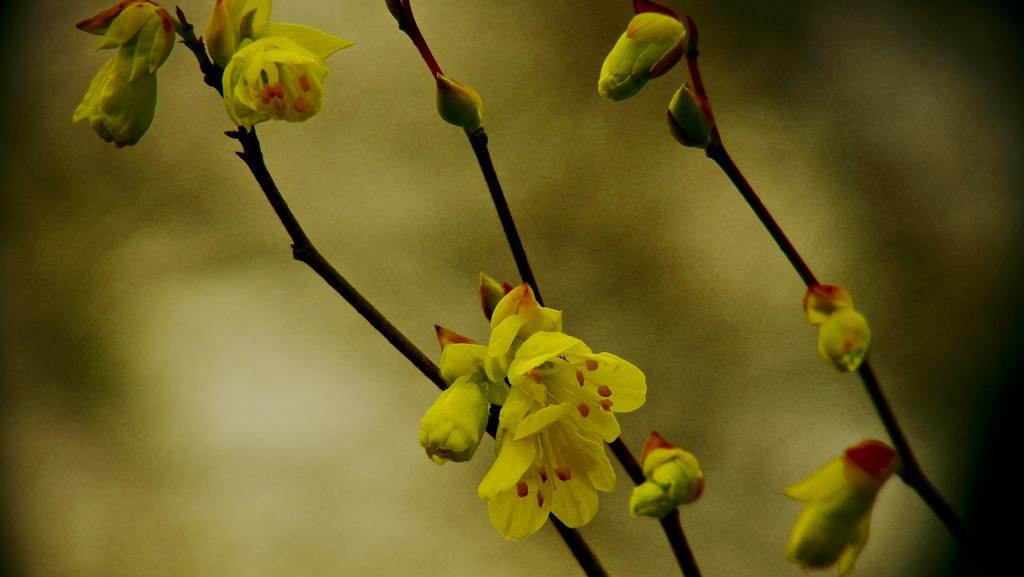What is located in the foreground of the image? There are flowers, buds, and stems in the foreground of the image. Can you describe the appearance of the flowers? The flowers are likely in various stages of blooming, as there are both buds and open flowers visible. What can be seen in the background of the image? The background of the image is blurry. How many rabbits can be seen hiding among the mint leaves in the image? There are no rabbits or mint leaves present in the image; it features flowers, buds, and stems in the foreground and a blurry background. 